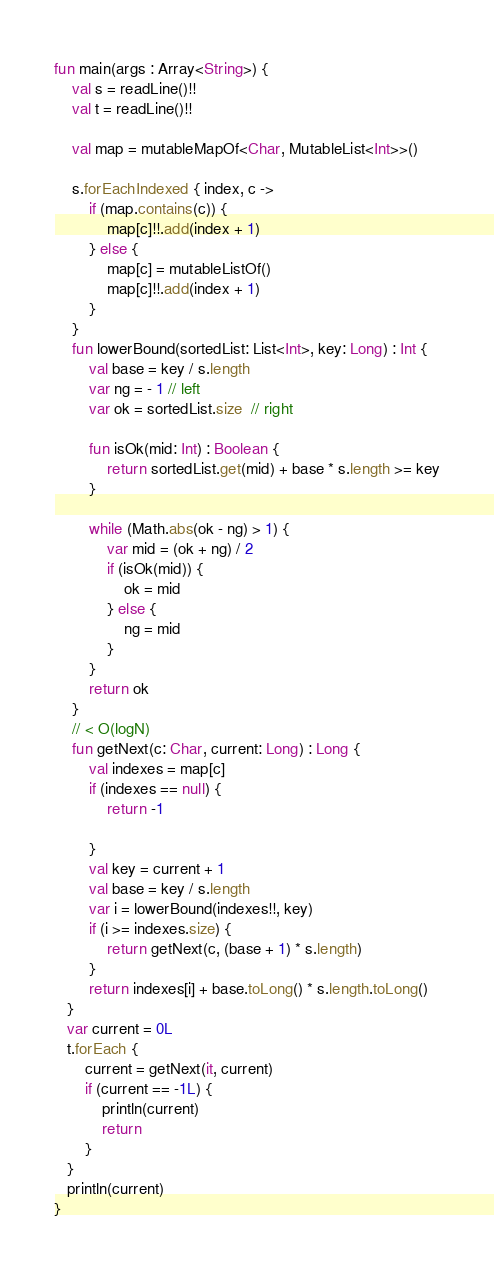<code> <loc_0><loc_0><loc_500><loc_500><_Kotlin_>fun main(args : Array<String>) {
    val s = readLine()!!
    val t = readLine()!!

    val map = mutableMapOf<Char, MutableList<Int>>()

    s.forEachIndexed { index, c ->
        if (map.contains(c)) {
            map[c]!!.add(index + 1)
        } else {
            map[c] = mutableListOf()
            map[c]!!.add(index + 1)
        }
    }
    fun lowerBound(sortedList: List<Int>, key: Long) : Int {
        val base = key / s.length
        var ng = - 1 // left
        var ok = sortedList.size  // right

        fun isOk(mid: Int) : Boolean {
            return sortedList.get(mid) + base * s.length >= key
        }

        while (Math.abs(ok - ng) > 1) {
            var mid = (ok + ng) / 2
            if (isOk(mid)) {
                ok = mid
            } else {
                ng = mid
            }
        }
        return ok
    }
    // < O(logN)
    fun getNext(c: Char, current: Long) : Long {
        val indexes = map[c]
        if (indexes == null) {
            return -1

        }
        val key = current + 1
        val base = key / s.length
        var i = lowerBound(indexes!!, key)
        if (i >= indexes.size) {
            return getNext(c, (base + 1) * s.length)
        }
        return indexes[i] + base.toLong() * s.length.toLong()
   }
   var current = 0L
   t.forEach {
       current = getNext(it, current)
       if (current == -1L) {
           println(current)
           return
       }
   }
   println(current)
}</code> 